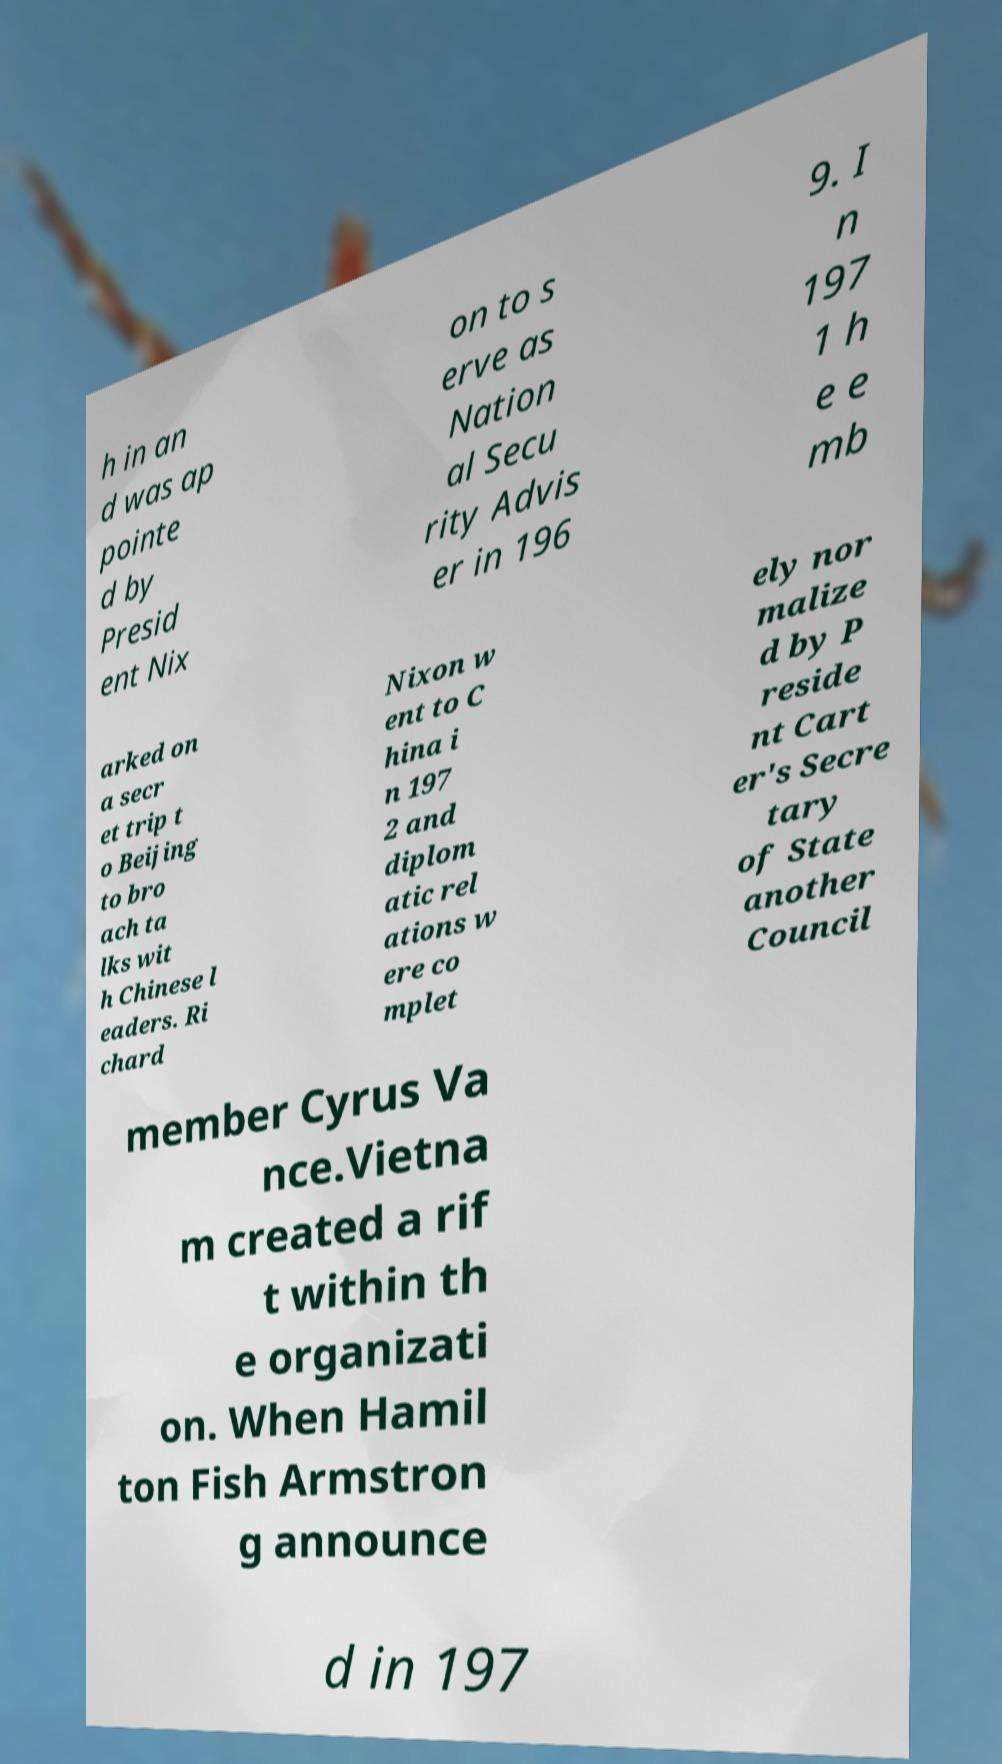I need the written content from this picture converted into text. Can you do that? h in an d was ap pointe d by Presid ent Nix on to s erve as Nation al Secu rity Advis er in 196 9. I n 197 1 h e e mb arked on a secr et trip t o Beijing to bro ach ta lks wit h Chinese l eaders. Ri chard Nixon w ent to C hina i n 197 2 and diplom atic rel ations w ere co mplet ely nor malize d by P reside nt Cart er's Secre tary of State another Council member Cyrus Va nce.Vietna m created a rif t within th e organizati on. When Hamil ton Fish Armstron g announce d in 197 